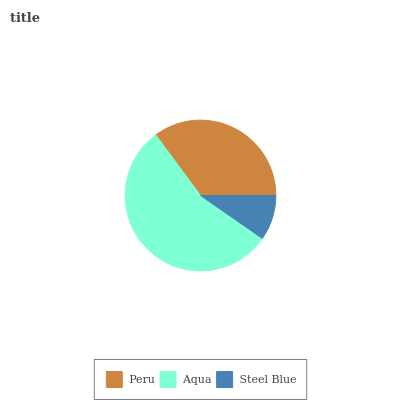Is Steel Blue the minimum?
Answer yes or no. Yes. Is Aqua the maximum?
Answer yes or no. Yes. Is Aqua the minimum?
Answer yes or no. No. Is Steel Blue the maximum?
Answer yes or no. No. Is Aqua greater than Steel Blue?
Answer yes or no. Yes. Is Steel Blue less than Aqua?
Answer yes or no. Yes. Is Steel Blue greater than Aqua?
Answer yes or no. No. Is Aqua less than Steel Blue?
Answer yes or no. No. Is Peru the high median?
Answer yes or no. Yes. Is Peru the low median?
Answer yes or no. Yes. Is Steel Blue the high median?
Answer yes or no. No. Is Steel Blue the low median?
Answer yes or no. No. 